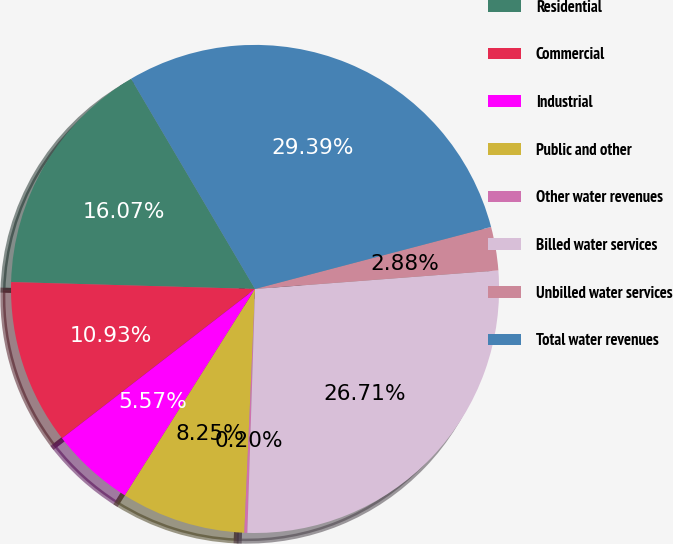<chart> <loc_0><loc_0><loc_500><loc_500><pie_chart><fcel>Residential<fcel>Commercial<fcel>Industrial<fcel>Public and other<fcel>Other water revenues<fcel>Billed water services<fcel>Unbilled water services<fcel>Total water revenues<nl><fcel>16.07%<fcel>10.93%<fcel>5.57%<fcel>8.25%<fcel>0.2%<fcel>26.71%<fcel>2.88%<fcel>29.39%<nl></chart> 